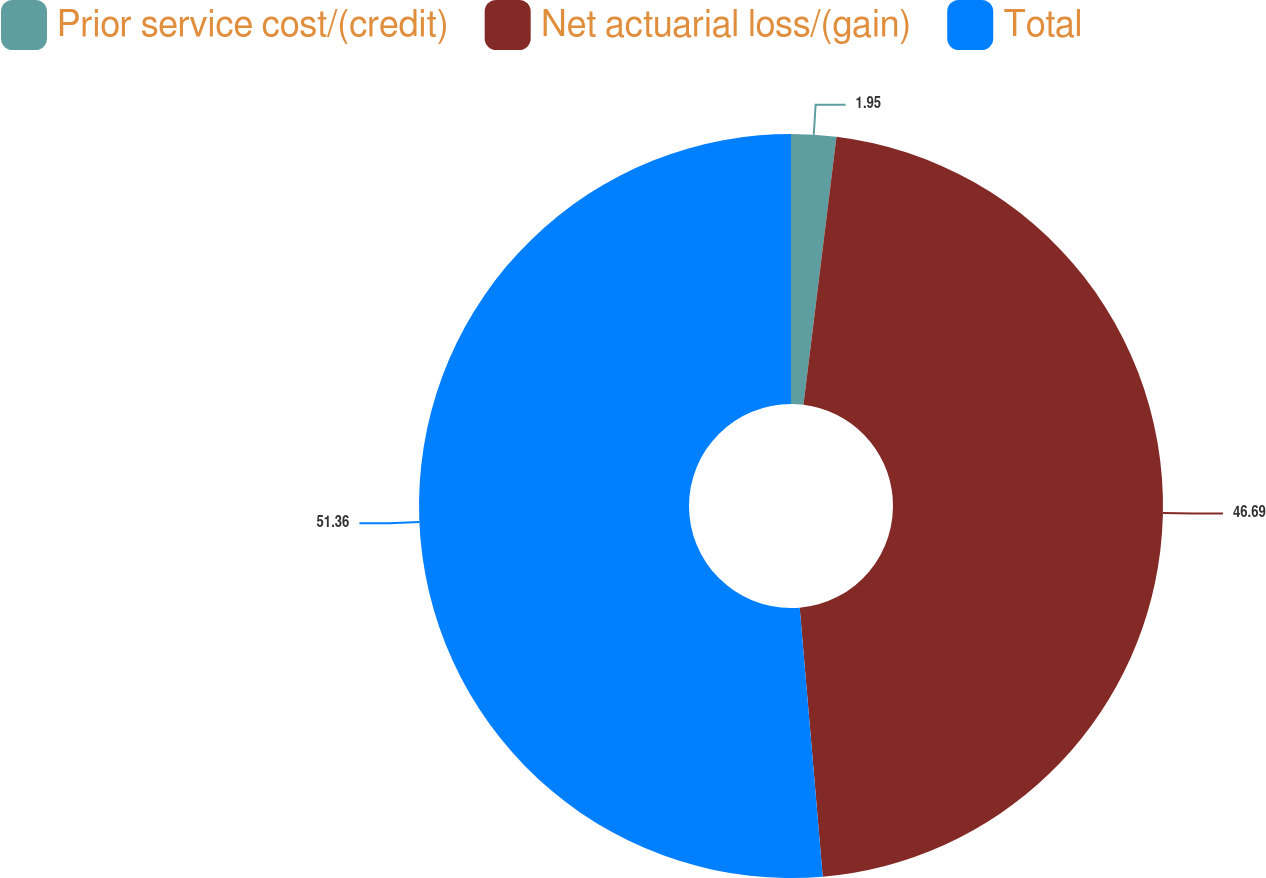Convert chart. <chart><loc_0><loc_0><loc_500><loc_500><pie_chart><fcel>Prior service cost/(credit)<fcel>Net actuarial loss/(gain)<fcel>Total<nl><fcel>1.95%<fcel>46.69%<fcel>51.36%<nl></chart> 